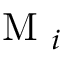<formula> <loc_0><loc_0><loc_500><loc_500>M _ { i }</formula> 